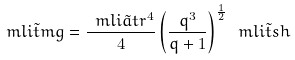<formula> <loc_0><loc_0><loc_500><loc_500>\ m l i { \tilde { t } } { m g } = \frac { \ m l i { \tilde { a } } { t r } ^ { 4 } } { 4 } \left ( \frac { q ^ { 3 } } { q + 1 } \right ) ^ { \frac { 1 } { 2 } } \ m l i { \tilde { t } } { s h }</formula> 